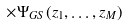<formula> <loc_0><loc_0><loc_500><loc_500>\times \Psi _ { G S } ( z _ { 1 } , \dots , z _ { M } )</formula> 